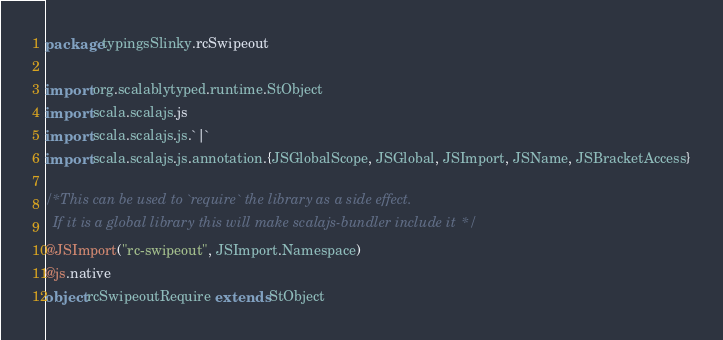<code> <loc_0><loc_0><loc_500><loc_500><_Scala_>package typingsSlinky.rcSwipeout

import org.scalablytyped.runtime.StObject
import scala.scalajs.js
import scala.scalajs.js.`|`
import scala.scalajs.js.annotation.{JSGlobalScope, JSGlobal, JSImport, JSName, JSBracketAccess}

/* This can be used to `require` the library as a side effect.
  If it is a global library this will make scalajs-bundler include it */
@JSImport("rc-swipeout", JSImport.Namespace)
@js.native
object rcSwipeoutRequire extends StObject
</code> 